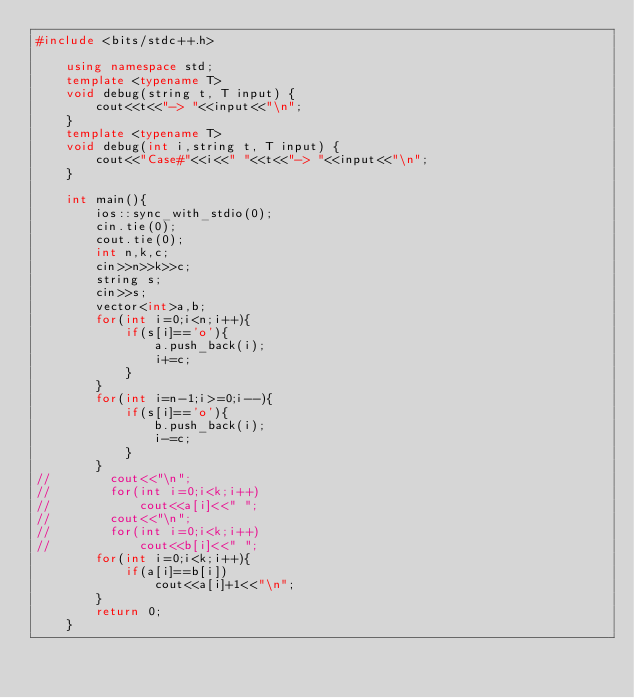<code> <loc_0><loc_0><loc_500><loc_500><_C++_>#include <bits/stdc++.h>

    using namespace std;
    template <typename T>
    void debug(string t, T input) {
        cout<<t<<"-> "<<input<<"\n";
    }
    template <typename T>
    void debug(int i,string t, T input) {
        cout<<"Case#"<<i<<" "<<t<<"-> "<<input<<"\n";
    }

    int main(){
        ios::sync_with_stdio(0);
        cin.tie(0);
        cout.tie(0);
        int n,k,c;
        cin>>n>>k>>c;
        string s;
        cin>>s;
        vector<int>a,b;
        for(int i=0;i<n;i++){
            if(s[i]=='o'){
                a.push_back(i);
                i+=c;
            }
        }
        for(int i=n-1;i>=0;i--){
            if(s[i]=='o'){
                b.push_back(i);
                i-=c;
            }
        }
//        cout<<"\n";
//        for(int i=0;i<k;i++)
//            cout<<a[i]<<" ";
//        cout<<"\n";
//        for(int i=0;i<k;i++)
//            cout<<b[i]<<" ";
        for(int i=0;i<k;i++){
            if(a[i]==b[i])
                cout<<a[i]+1<<"\n";
        }
        return 0;
    }
</code> 